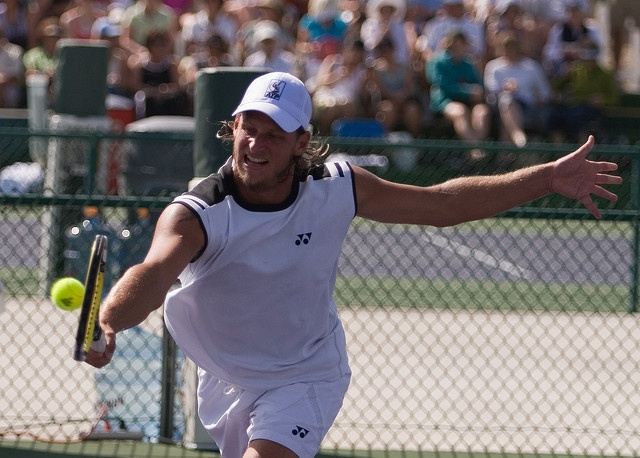Describe the objects in this image and their specific colors. I can see people in black, gray, and maroon tones, people in black, gray, darkblue, and teal tones, people in black, gray, and darkgray tones, people in black, gray, and darkgray tones, and people in black and gray tones in this image. 